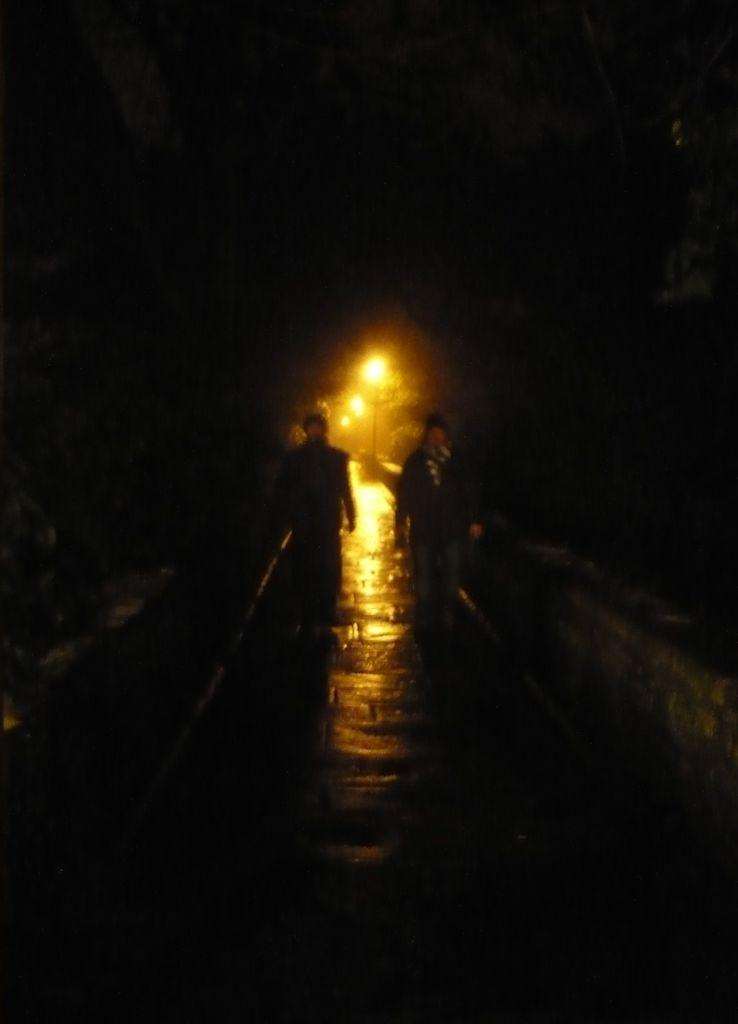What are the two persons in the image doing? The two persons in the image are walking. What can be seen in the background of the image? There are light poles in the background of the image. What is the topic of the argument between the two persons in the image? There is no argument present in the image; the two persons are simply walking. 